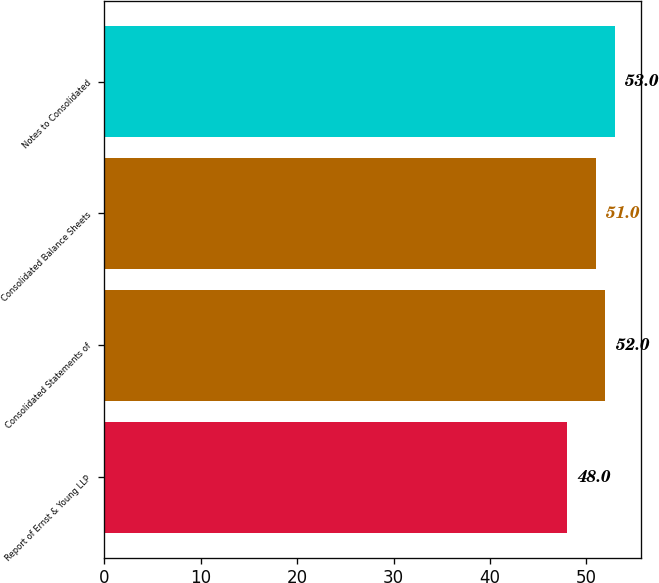<chart> <loc_0><loc_0><loc_500><loc_500><bar_chart><fcel>Report of Ernst & Young LLP<fcel>Consolidated Statements of<fcel>Consolidated Balance Sheets<fcel>Notes to Consolidated<nl><fcel>48<fcel>52<fcel>51<fcel>53<nl></chart> 